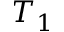<formula> <loc_0><loc_0><loc_500><loc_500>T _ { 1 }</formula> 